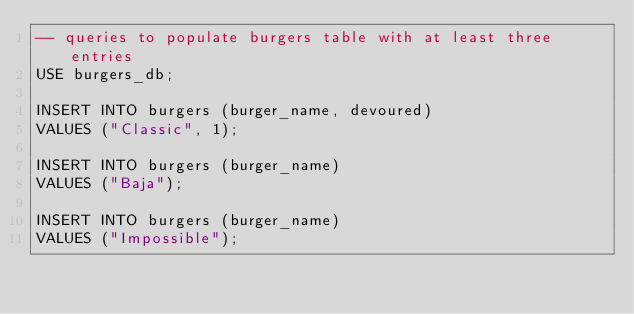Convert code to text. <code><loc_0><loc_0><loc_500><loc_500><_SQL_>-- queries to populate burgers table with at least three entries
USE burgers_db;

INSERT INTO burgers (burger_name, devoured)
VALUES ("Classic", 1);

INSERT INTO burgers (burger_name)
VALUES ("Baja");

INSERT INTO burgers (burger_name)
VALUES ("Impossible");</code> 